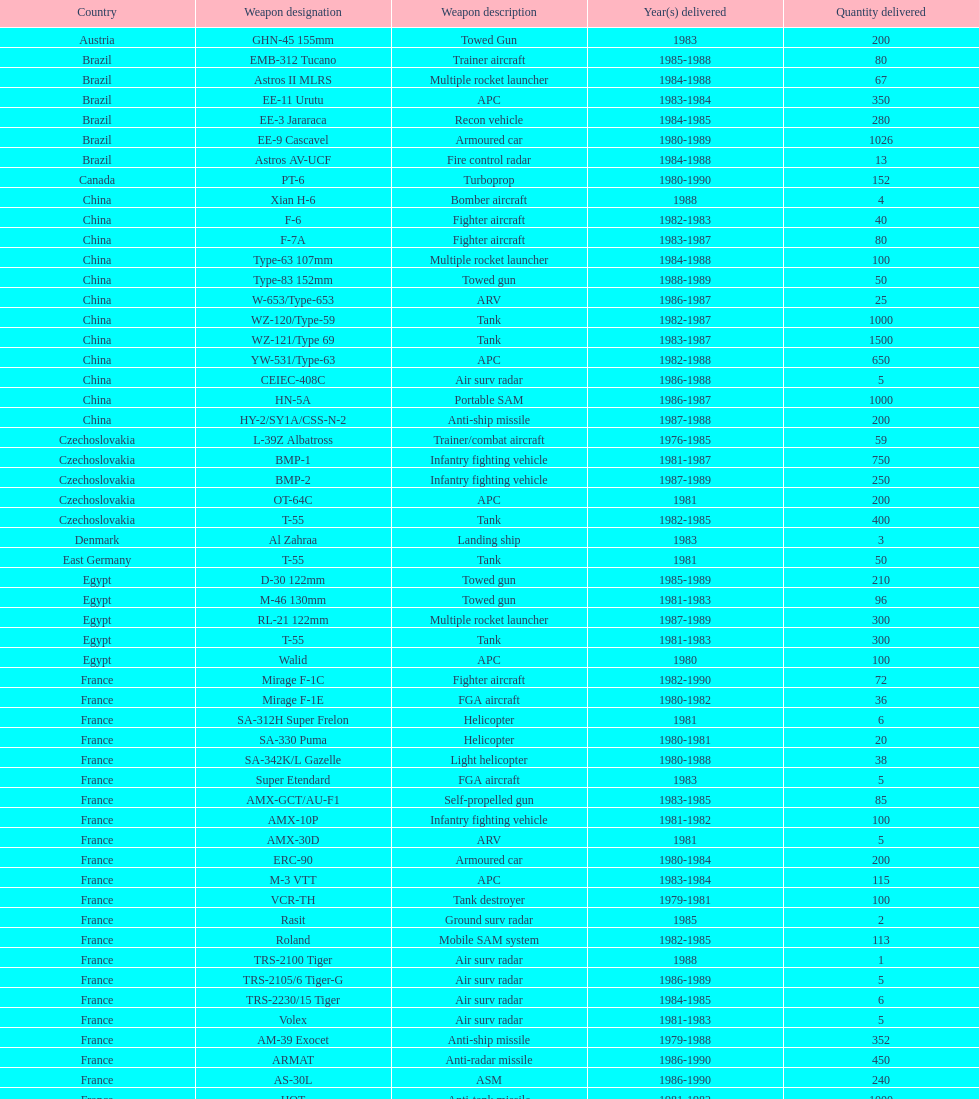Give me the full table as a dictionary. {'header': ['Country', 'Weapon designation', 'Weapon description', 'Year(s) delivered', 'Quantity delivered'], 'rows': [['Austria', 'GHN-45 155mm', 'Towed Gun', '1983', '200'], ['Brazil', 'EMB-312 Tucano', 'Trainer aircraft', '1985-1988', '80'], ['Brazil', 'Astros II MLRS', 'Multiple rocket launcher', '1984-1988', '67'], ['Brazil', 'EE-11 Urutu', 'APC', '1983-1984', '350'], ['Brazil', 'EE-3 Jararaca', 'Recon vehicle', '1984-1985', '280'], ['Brazil', 'EE-9 Cascavel', 'Armoured car', '1980-1989', '1026'], ['Brazil', 'Astros AV-UCF', 'Fire control radar', '1984-1988', '13'], ['Canada', 'PT-6', 'Turboprop', '1980-1990', '152'], ['China', 'Xian H-6', 'Bomber aircraft', '1988', '4'], ['China', 'F-6', 'Fighter aircraft', '1982-1983', '40'], ['China', 'F-7A', 'Fighter aircraft', '1983-1987', '80'], ['China', 'Type-63 107mm', 'Multiple rocket launcher', '1984-1988', '100'], ['China', 'Type-83 152mm', 'Towed gun', '1988-1989', '50'], ['China', 'W-653/Type-653', 'ARV', '1986-1987', '25'], ['China', 'WZ-120/Type-59', 'Tank', '1982-1987', '1000'], ['China', 'WZ-121/Type 69', 'Tank', '1983-1987', '1500'], ['China', 'YW-531/Type-63', 'APC', '1982-1988', '650'], ['China', 'CEIEC-408C', 'Air surv radar', '1986-1988', '5'], ['China', 'HN-5A', 'Portable SAM', '1986-1987', '1000'], ['China', 'HY-2/SY1A/CSS-N-2', 'Anti-ship missile', '1987-1988', '200'], ['Czechoslovakia', 'L-39Z Albatross', 'Trainer/combat aircraft', '1976-1985', '59'], ['Czechoslovakia', 'BMP-1', 'Infantry fighting vehicle', '1981-1987', '750'], ['Czechoslovakia', 'BMP-2', 'Infantry fighting vehicle', '1987-1989', '250'], ['Czechoslovakia', 'OT-64C', 'APC', '1981', '200'], ['Czechoslovakia', 'T-55', 'Tank', '1982-1985', '400'], ['Denmark', 'Al Zahraa', 'Landing ship', '1983', '3'], ['East Germany', 'T-55', 'Tank', '1981', '50'], ['Egypt', 'D-30 122mm', 'Towed gun', '1985-1989', '210'], ['Egypt', 'M-46 130mm', 'Towed gun', '1981-1983', '96'], ['Egypt', 'RL-21 122mm', 'Multiple rocket launcher', '1987-1989', '300'], ['Egypt', 'T-55', 'Tank', '1981-1983', '300'], ['Egypt', 'Walid', 'APC', '1980', '100'], ['France', 'Mirage F-1C', 'Fighter aircraft', '1982-1990', '72'], ['France', 'Mirage F-1E', 'FGA aircraft', '1980-1982', '36'], ['France', 'SA-312H Super Frelon', 'Helicopter', '1981', '6'], ['France', 'SA-330 Puma', 'Helicopter', '1980-1981', '20'], ['France', 'SA-342K/L Gazelle', 'Light helicopter', '1980-1988', '38'], ['France', 'Super Etendard', 'FGA aircraft', '1983', '5'], ['France', 'AMX-GCT/AU-F1', 'Self-propelled gun', '1983-1985', '85'], ['France', 'AMX-10P', 'Infantry fighting vehicle', '1981-1982', '100'], ['France', 'AMX-30D', 'ARV', '1981', '5'], ['France', 'ERC-90', 'Armoured car', '1980-1984', '200'], ['France', 'M-3 VTT', 'APC', '1983-1984', '115'], ['France', 'VCR-TH', 'Tank destroyer', '1979-1981', '100'], ['France', 'Rasit', 'Ground surv radar', '1985', '2'], ['France', 'Roland', 'Mobile SAM system', '1982-1985', '113'], ['France', 'TRS-2100 Tiger', 'Air surv radar', '1988', '1'], ['France', 'TRS-2105/6 Tiger-G', 'Air surv radar', '1986-1989', '5'], ['France', 'TRS-2230/15 Tiger', 'Air surv radar', '1984-1985', '6'], ['France', 'Volex', 'Air surv radar', '1981-1983', '5'], ['France', 'AM-39 Exocet', 'Anti-ship missile', '1979-1988', '352'], ['France', 'ARMAT', 'Anti-radar missile', '1986-1990', '450'], ['France', 'AS-30L', 'ASM', '1986-1990', '240'], ['France', 'HOT', 'Anti-tank missile', '1981-1982', '1000'], ['France', 'R-550 Magic-1', 'SRAAM', '1981-1985', '534'], ['France', 'Roland-2', 'SAM', '1981-1990', '2260'], ['France', 'Super 530F', 'BVRAAM', '1981-1985', '300'], ['West Germany', 'BK-117', 'Helicopter', '1984-1989', '22'], ['West Germany', 'Bo-105C', 'Light Helicopter', '1979-1982', '20'], ['West Germany', 'Bo-105L', 'Light Helicopter', '1988', '6'], ['Hungary', 'PSZH-D-994', 'APC', '1981', '300'], ['Italy', 'A-109 Hirundo', 'Light Helicopter', '1982', '2'], ['Italy', 'S-61', 'Helicopter', '1982', '6'], ['Italy', 'Stromboli class', 'Support ship', '1981', '1'], ['Jordan', 'S-76 Spirit', 'Helicopter', '1985', '2'], ['Poland', 'Mi-2/Hoplite', 'Helicopter', '1984-1985', '15'], ['Poland', 'MT-LB', 'APC', '1983-1990', '750'], ['Poland', 'T-55', 'Tank', '1981-1982', '400'], ['Poland', 'T-72M1', 'Tank', '1982-1990', '500'], ['Romania', 'T-55', 'Tank', '1982-1984', '150'], ['Yugoslavia', 'M-87 Orkan 262mm', 'Multiple rocket launcher', '1988', '2'], ['South Africa', 'G-5 155mm', 'Towed gun', '1985-1988', '200'], ['Switzerland', 'PC-7 Turbo trainer', 'Trainer aircraft', '1980-1983', '52'], ['Switzerland', 'PC-9', 'Trainer aircraft', '1987-1990', '20'], ['Switzerland', 'Roland', 'APC/IFV', '1981', '100'], ['United Kingdom', 'Chieftain/ARV', 'ARV', '1982', '29'], ['United Kingdom', 'Cymbeline', 'Arty locating radar', '1986-1988', '10'], ['United States', 'MD-500MD Defender', 'Light Helicopter', '1983', '30'], ['United States', 'Hughes-300/TH-55', 'Light Helicopter', '1983', '30'], ['United States', 'MD-530F', 'Light Helicopter', '1986', '26'], ['United States', 'Bell 214ST', 'Helicopter', '1988', '31'], ['Soviet Union', 'Il-76M/Candid-B', 'Strategic airlifter', '1978-1984', '33'], ['Soviet Union', 'Mi-24D/Mi-25/Hind-D', 'Attack helicopter', '1978-1984', '12'], ['Soviet Union', 'Mi-8/Mi-17/Hip-H', 'Transport helicopter', '1986-1987', '37'], ['Soviet Union', 'Mi-8TV/Hip-F', 'Transport helicopter', '1984', '30'], ['Soviet Union', 'Mig-21bis/Fishbed-N', 'Fighter aircraft', '1983-1984', '61'], ['Soviet Union', 'Mig-23BN/Flogger-H', 'FGA aircraft', '1984-1985', '50'], ['Soviet Union', 'Mig-25P/Foxbat-A', 'Interceptor aircraft', '1980-1985', '55'], ['Soviet Union', 'Mig-25RB/Foxbat-B', 'Recon aircraft', '1982', '8'], ['Soviet Union', 'Mig-29/Fulcrum-A', 'Fighter aircraft', '1986-1989', '41'], ['Soviet Union', 'Su-22/Fitter-H/J/K', 'FGA aircraft', '1986-1987', '61'], ['Soviet Union', 'Su-25/Frogfoot-A', 'Ground attack aircraft', '1986-1987', '84'], ['Soviet Union', '2A36 152mm', 'Towed gun', '1986-1988', '180'], ['Soviet Union', '2S1 122mm', 'Self-Propelled Howitzer', '1980-1989', '150'], ['Soviet Union', '2S3 152mm', 'Self-propelled gun', '1980-1989', '150'], ['Soviet Union', '2S4 240mm', 'Self-propelled mortar', '1983', '10'], ['Soviet Union', '9P117/SS-1 Scud TEL', 'SSM launcher', '1983-1984', '10'], ['Soviet Union', 'BM-21 Grad 122mm', 'Multiple rocket launcher', '1983-1988', '560'], ['Soviet Union', 'D-30 122mm', 'Towed gun', '1982-1988', '576'], ['Soviet Union', 'M-240 240mm', 'Mortar', '1981', '25'], ['Soviet Union', 'M-46 130mm', 'Towed Gun', '1982-1987', '576'], ['Soviet Union', '9K35 Strela-10/SA-13', 'AAV(M)', '1985', '30'], ['Soviet Union', 'BMD-1', 'IFV', '1981', '10'], ['Soviet Union', 'PT-76', 'Light tank', '1984', '200'], ['Soviet Union', 'SA-9/9P31', 'AAV(M)', '1982-1985', '160'], ['Soviet Union', 'Long Track', 'Air surv radar', '1980-1984', '10'], ['Soviet Union', 'SA-8b/9K33M Osa AK', 'Mobile SAM system', '1982-1985', '50'], ['Soviet Union', 'Thin Skin', 'Air surv radar', '1980-1984', '5'], ['Soviet Union', '9M111/AT-4 Spigot', 'Anti-tank missile', '1986-1989', '3000'], ['Soviet Union', '9M37/SA-13 Gopher', 'SAM', '1985-1986', '960'], ['Soviet Union', 'KSR-5/AS-6 Kingfish', 'Anti-ship missile', '1984', '36'], ['Soviet Union', 'Kh-28/AS-9 Kyle', 'Anti-radar missile', '1983-1988', '250'], ['Soviet Union', 'R-13S/AA2S Atoll', 'SRAAM', '1984-1987', '1080'], ['Soviet Union', 'R-17/SS-1c Scud-B', 'SSM', '1982-1988', '840'], ['Soviet Union', 'R-27/AA-10 Alamo', 'BVRAAM', '1986-1989', '246'], ['Soviet Union', 'R-40R/AA-6 Acrid', 'BVRAAM', '1980-1985', '660'], ['Soviet Union', 'R-60/AA-8 Aphid', 'SRAAM', '1986-1989', '582'], ['Soviet Union', 'SA-8b Gecko/9M33M', 'SAM', '1982-1985', '1290'], ['Soviet Union', 'SA-9 Gaskin/9M31', 'SAM', '1982-1985', '1920'], ['Soviet Union', 'Strela-3/SA-14 Gremlin', 'Portable SAM', '1987-1988', '500']]} What is the overall amount of tanks that china has supplied to iraq? 2500. 